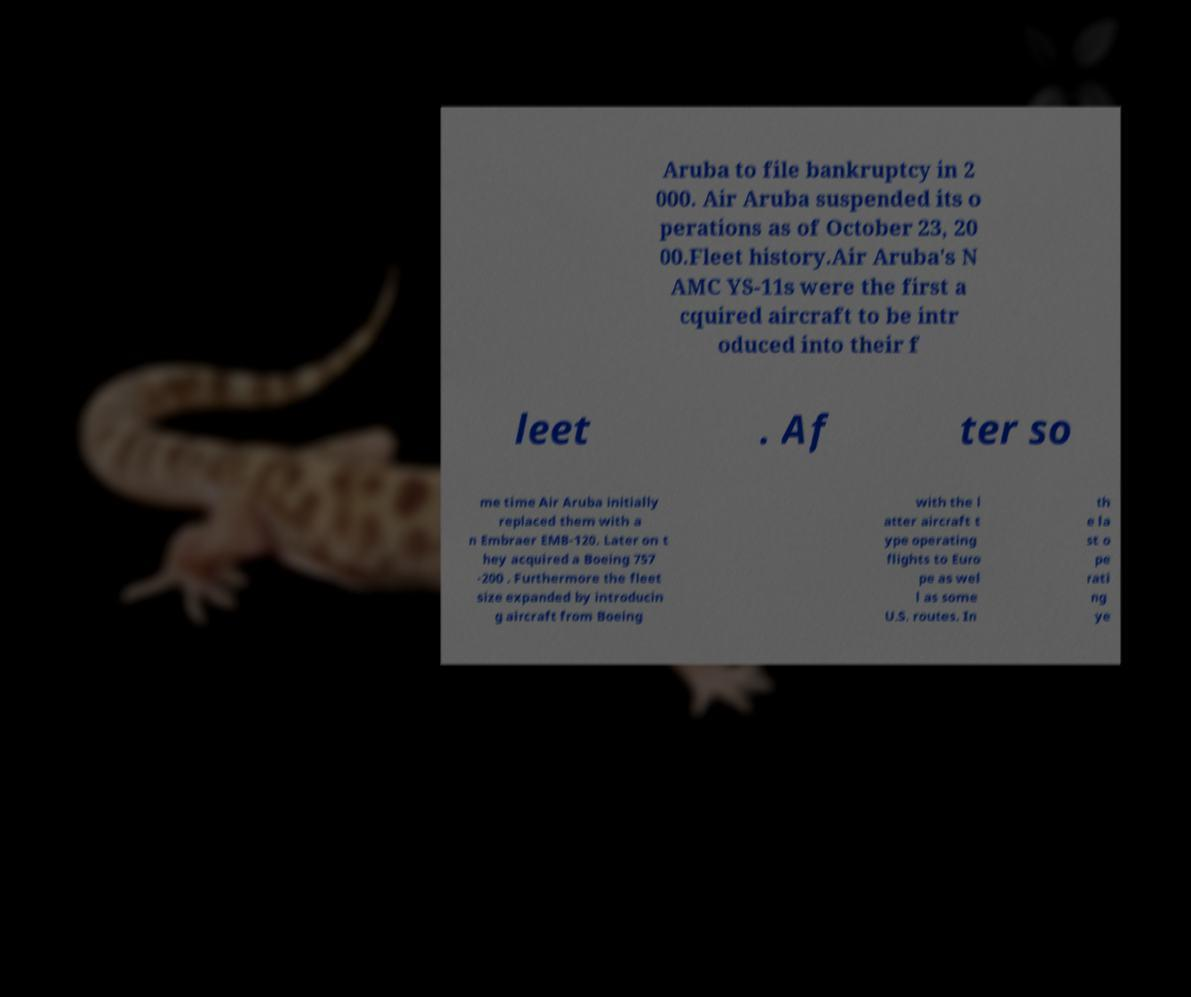I need the written content from this picture converted into text. Can you do that? Aruba to file bankruptcy in 2 000. Air Aruba suspended its o perations as of October 23, 20 00.Fleet history.Air Aruba's N AMC YS-11s were the first a cquired aircraft to be intr oduced into their f leet . Af ter so me time Air Aruba initially replaced them with a n Embraer EMB-120. Later on t hey acquired a Boeing 757 -200 . Furthermore the fleet size expanded by introducin g aircraft from Boeing with the l atter aircraft t ype operating flights to Euro pe as wel l as some U.S. routes. In th e la st o pe rati ng ye 